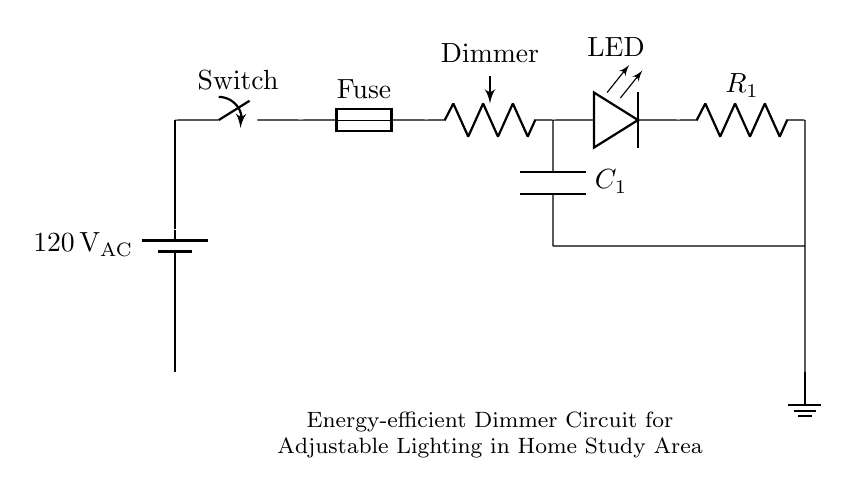What is the voltage of this circuit? The voltage source in this circuit is labeled as 120 volts AC, which indicates the potential difference provided to the circuit components.
Answer: 120 volts AC What type of component is the dimmer? The dimmer in the circuit is represented as a potentiometer, which is a variable resistor that allows adjustment of the light intensity.
Answer: Potentiometer How many resistors are in this circuit? There are two resistors present: one is the dimmer (potentiometer) and the other is labeled as R1, making a total of two resistors.
Answer: Two What component is used for smoothing in the circuit? The circuit includes a capacitor labeled as C1, which is used to smooth the output voltage by filtering out fluctuations in the signals.
Answer: Capacitor What is the purpose of the fuse in the circuit? The fuse is included to protect the circuit from excessive current flow by breaking the circuit if the current exceeds a safe limit, preventing damage.
Answer: Protection How does the dimmer affect the LED brightness? The brightness of the LED can be adjusted based on the resistance provided by the dimmer; increasing resistance reduces current flow, dimming the LED.
Answer: Adjusts brightness Where is the ground connection in this circuit? The ground connection is represented at the bottom of the circuit, where it connects to the resistor R1, establishing a reference point for the entire circuit.
Answer: Bottom of the circuit 